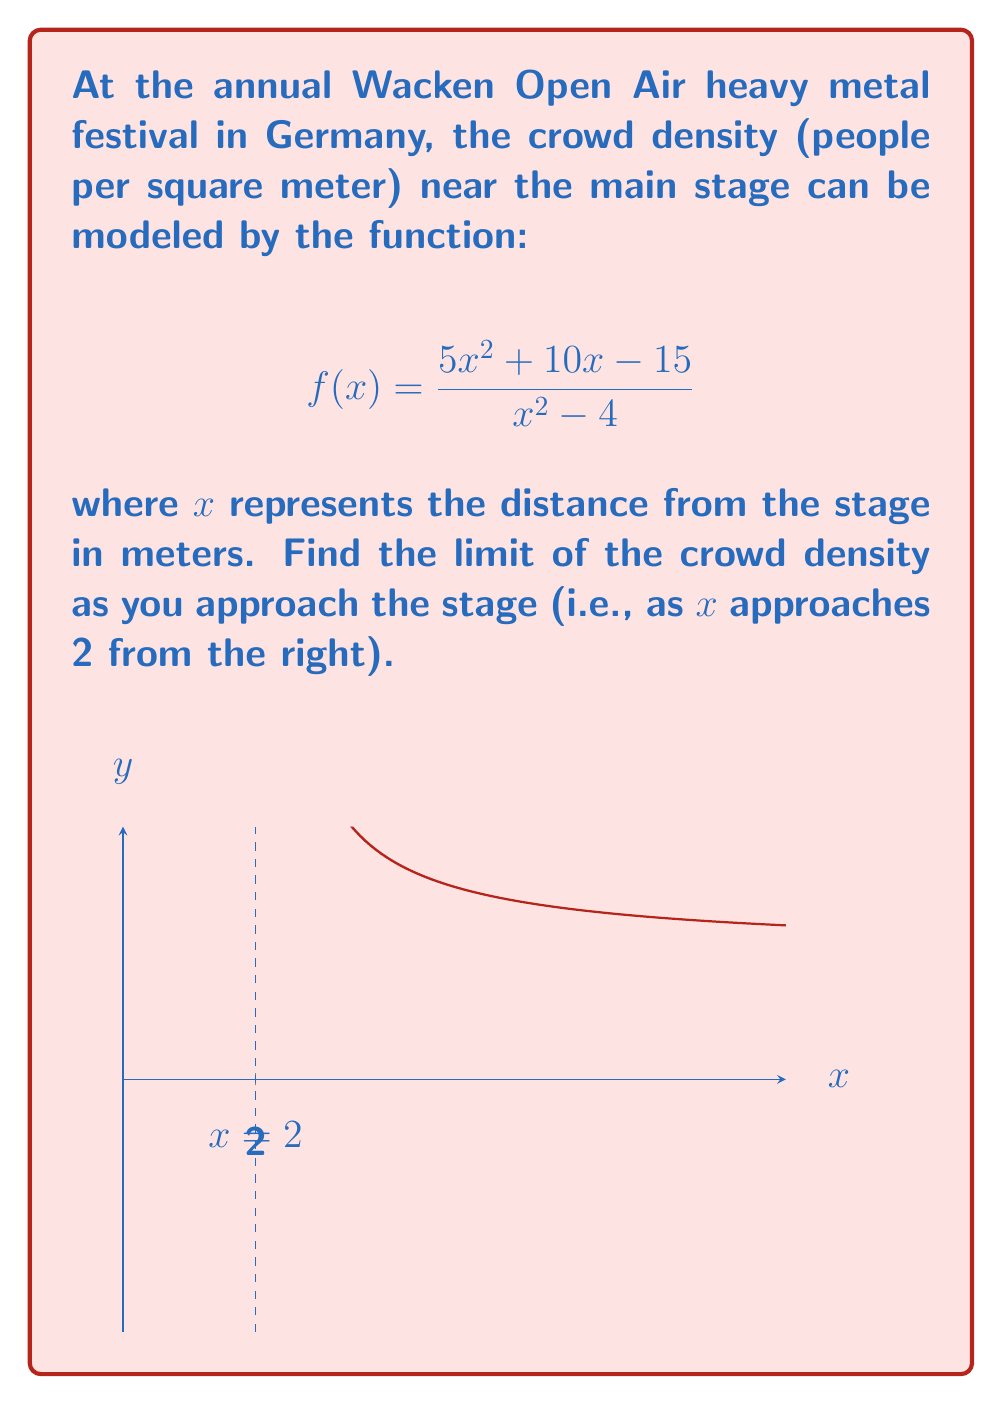Can you answer this question? Let's approach this step-by-step:

1) We need to find $\lim_{x \to 2^+} \frac{5x^2 + 10x - 15}{x^2 - 4}$

2) First, let's try direct substitution:
   $$\frac{5(2)^2 + 10(2) - 15}{(2)^2 - 4} = \frac{20 + 20 - 15}{4 - 4} = \frac{25}{0}$$
   This results in an indeterminate form (division by zero).

3) Since we have a rational function with a zero in the denominator, let's try factoring both numerator and denominator:

   Numerator: $5x^2 + 10x - 15 = 5(x^2 + 2x - 3) = 5(x+3)(x-1)$
   Denominator: $x^2 - 4 = (x+2)(x-2)$

4) Now our function looks like:
   $$f(x) = \frac{5(x+3)(x-1)}{(x+2)(x-2)}$$

5) We can cancel the $(x-2)$ factor:
   $$\lim_{x \to 2^+} \frac{5(x+3)(x-1)}{(x+2)(x-2)} = \lim_{x \to 2^+} \frac{5(x+3)(x-1)}{x+2}$$

6) Now we can directly substitute $x=2$:
   $$\lim_{x \to 2^+} \frac{5(x+3)(x-1)}{x+2} = \frac{5(2+3)(2-1)}{2+2} = \frac{5(5)(1)}{4} = \frac{25}{4}$$

Therefore, as you approach the stage, the crowd density approaches 6.25 people per square meter.
Answer: $\frac{25}{4}$ or $6.25$ 